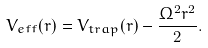Convert formula to latex. <formula><loc_0><loc_0><loc_500><loc_500>V _ { e f f } ( r ) = V _ { t r a p } ( r ) - \frac { \Omega ^ { 2 } r ^ { 2 } } { 2 } .</formula> 